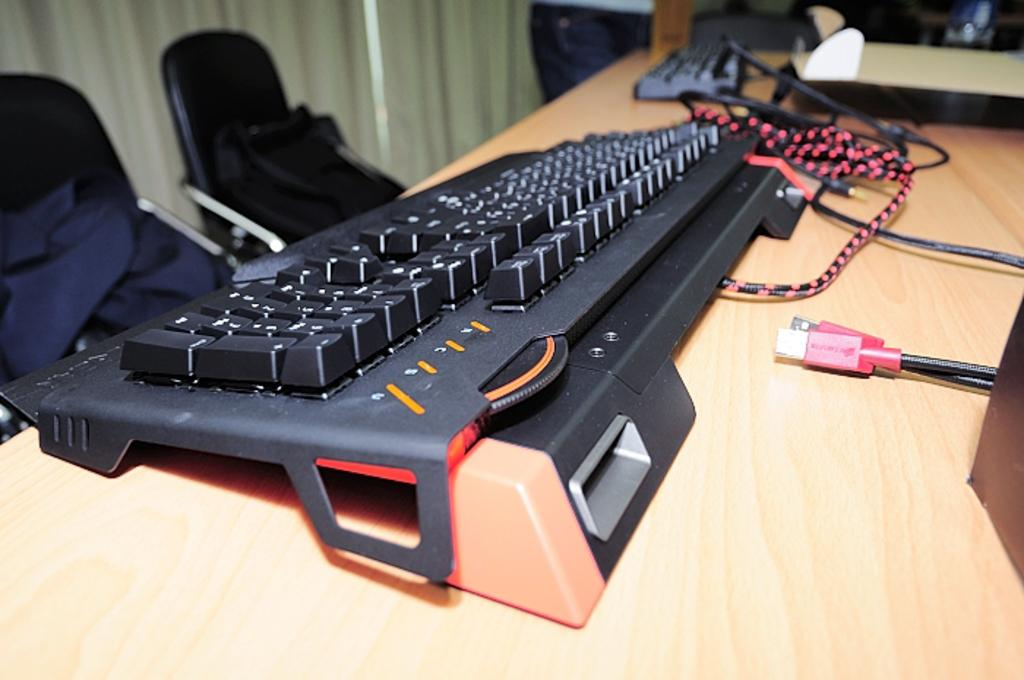What is the main object in the image? There is a keyboard in the image. Are there any additional items visible in the image? Yes, there are wires visible in the image. How many chairs are present in the image? There are two chairs in the image. What type of stamp can be seen on the keyboard in the image? There is no stamp present on the keyboard in the image. What kind of chain is connecting the two chairs in the image? There are no chains connecting the chairs in the image. 